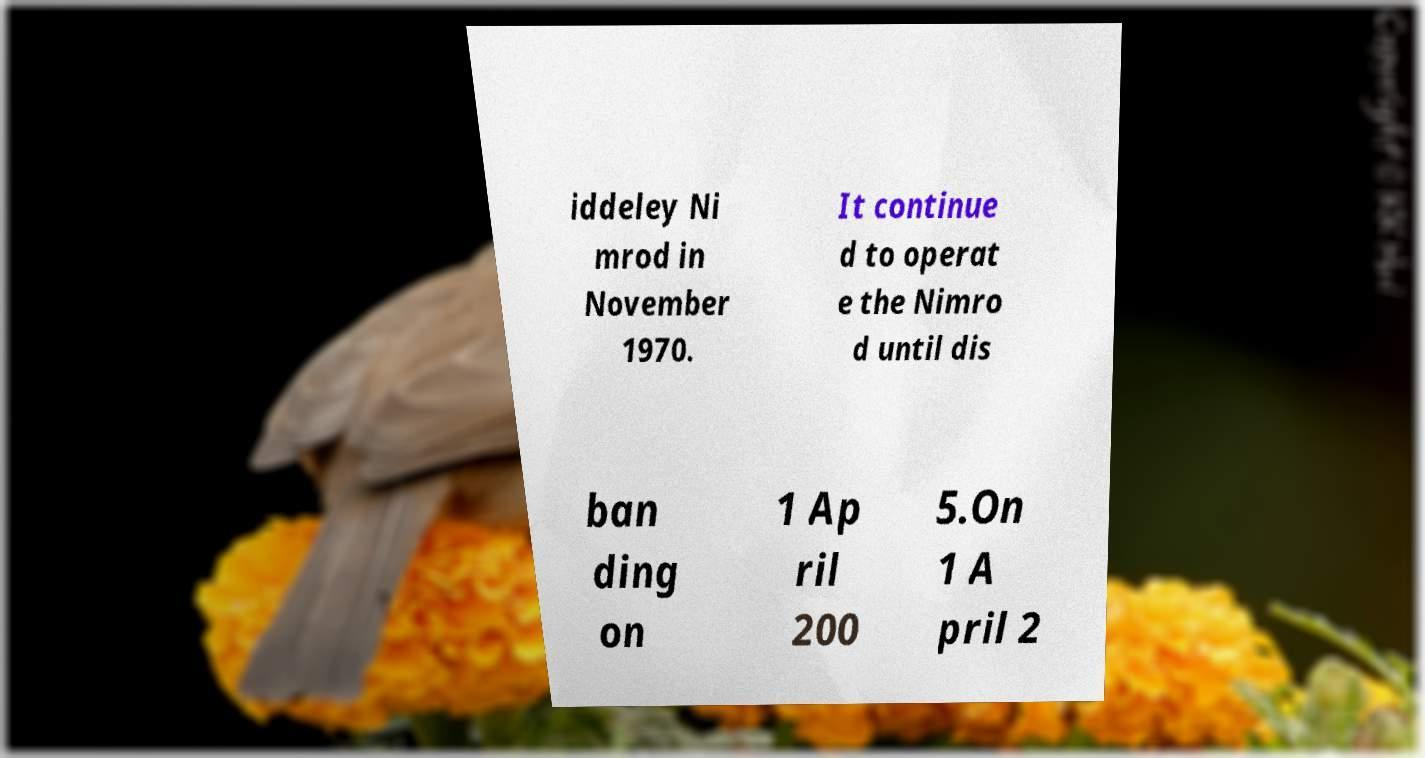What messages or text are displayed in this image? I need them in a readable, typed format. iddeley Ni mrod in November 1970. It continue d to operat e the Nimro d until dis ban ding on 1 Ap ril 200 5.On 1 A pril 2 